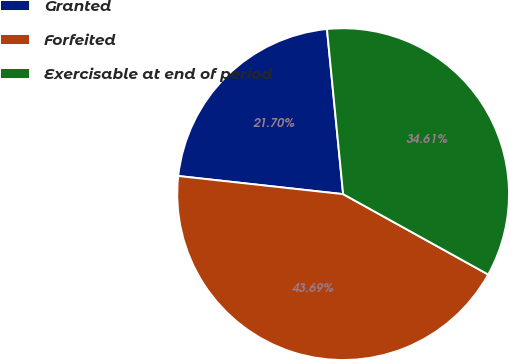<chart> <loc_0><loc_0><loc_500><loc_500><pie_chart><fcel>Granted<fcel>Forfeited<fcel>Exercisable at end of period<nl><fcel>21.7%<fcel>43.69%<fcel>34.61%<nl></chart> 